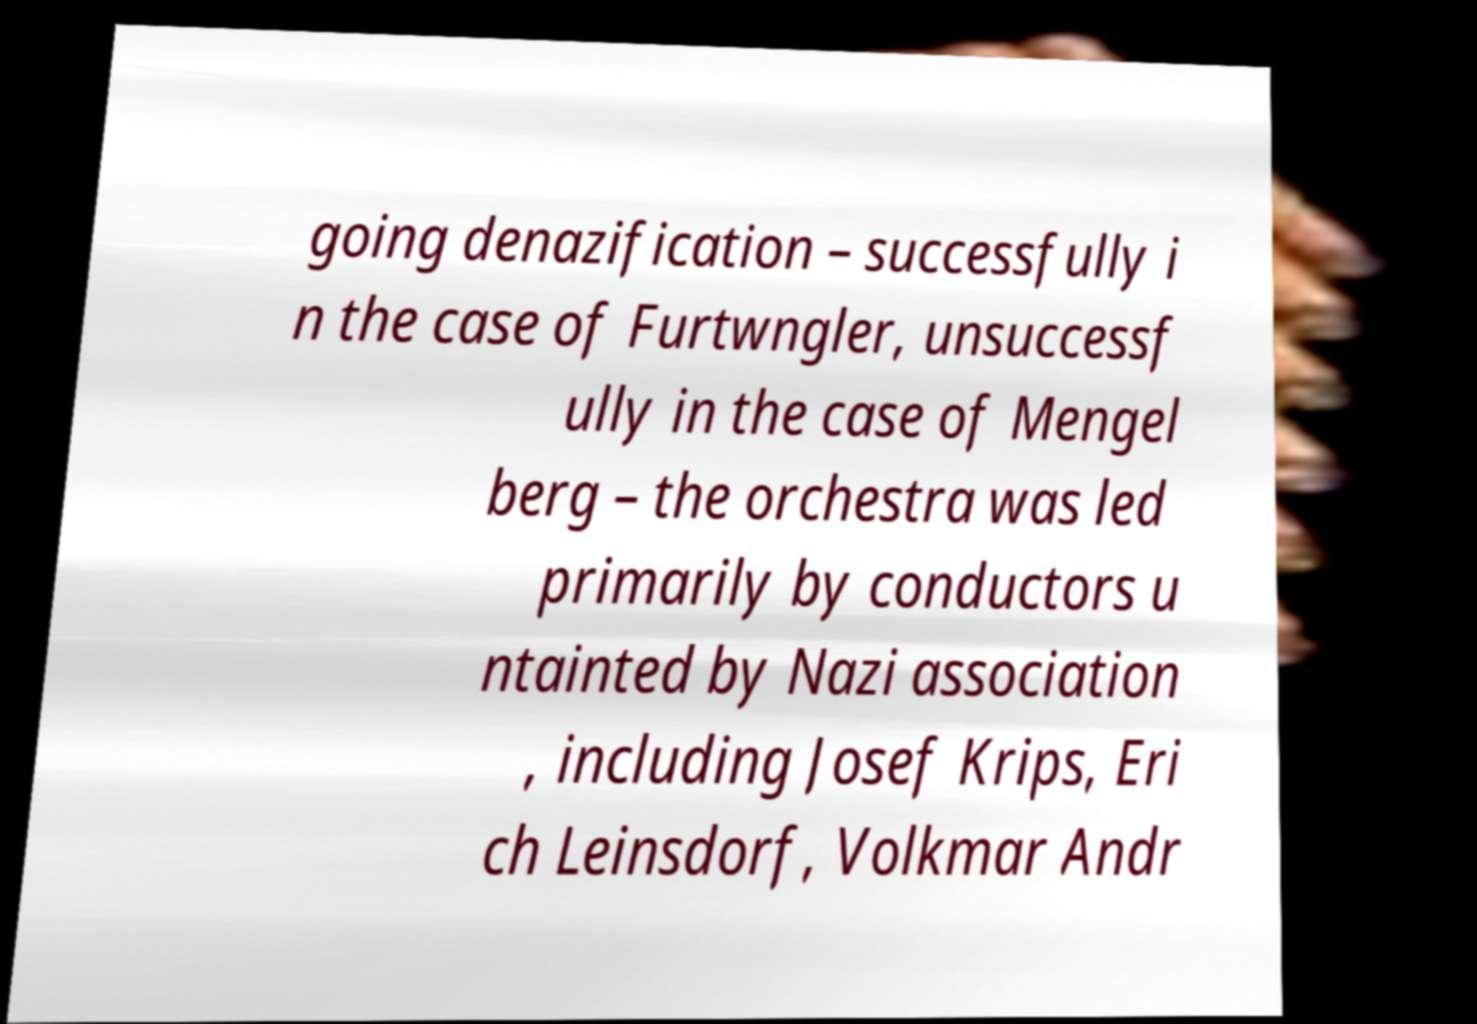Could you assist in decoding the text presented in this image and type it out clearly? going denazification – successfully i n the case of Furtwngler, unsuccessf ully in the case of Mengel berg – the orchestra was led primarily by conductors u ntainted by Nazi association , including Josef Krips, Eri ch Leinsdorf, Volkmar Andr 